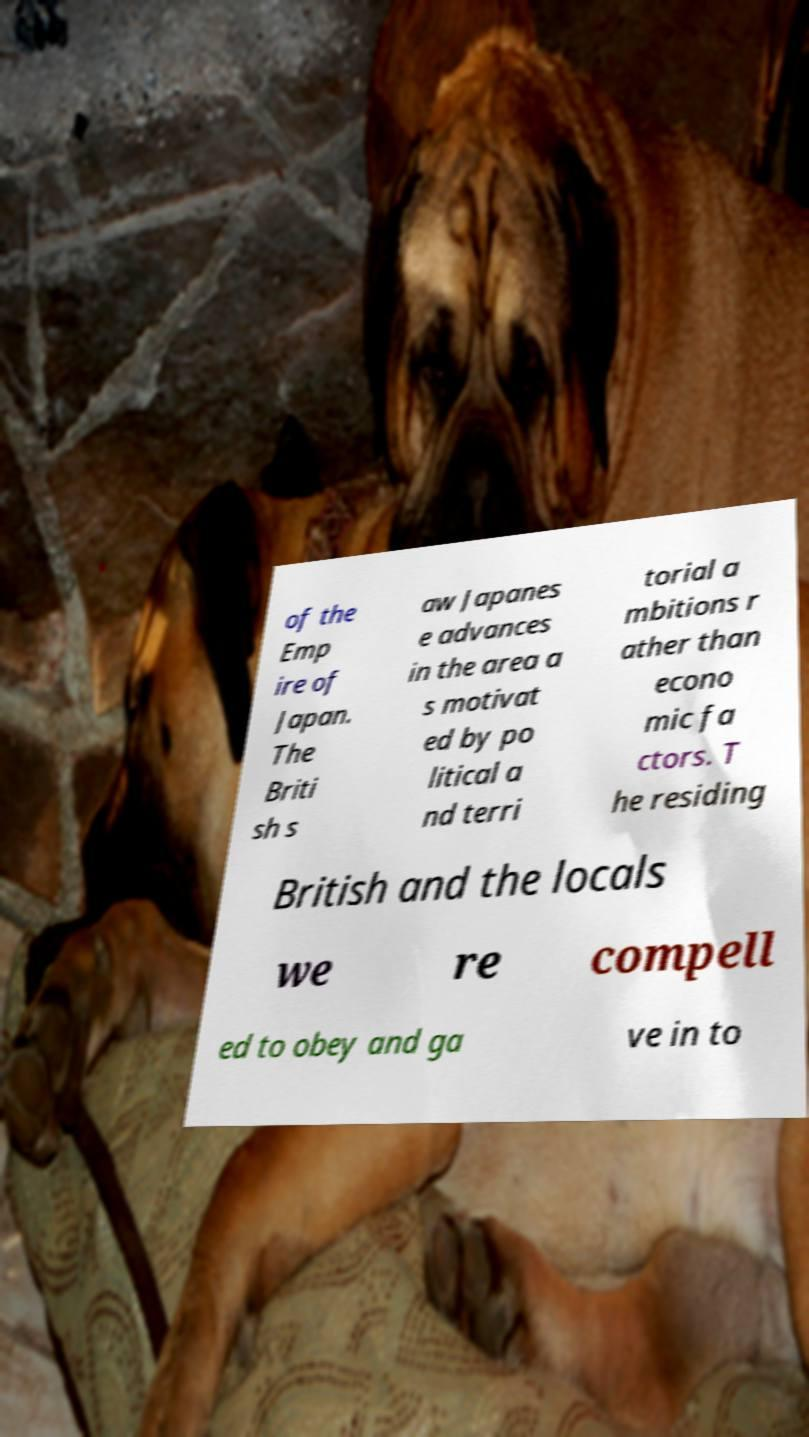Could you extract and type out the text from this image? of the Emp ire of Japan. The Briti sh s aw Japanes e advances in the area a s motivat ed by po litical a nd terri torial a mbitions r ather than econo mic fa ctors. T he residing British and the locals we re compell ed to obey and ga ve in to 